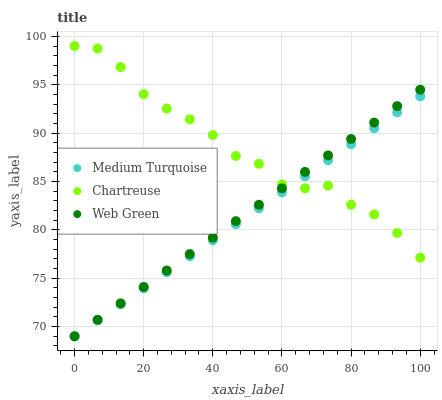Does Medium Turquoise have the minimum area under the curve?
Answer yes or no. Yes. Does Chartreuse have the maximum area under the curve?
Answer yes or no. Yes. Does Web Green have the minimum area under the curve?
Answer yes or no. No. Does Web Green have the maximum area under the curve?
Answer yes or no. No. Is Medium Turquoise the smoothest?
Answer yes or no. Yes. Is Chartreuse the roughest?
Answer yes or no. Yes. Is Web Green the smoothest?
Answer yes or no. No. Is Web Green the roughest?
Answer yes or no. No. Does Web Green have the lowest value?
Answer yes or no. Yes. Does Chartreuse have the highest value?
Answer yes or no. Yes. Does Web Green have the highest value?
Answer yes or no. No. Does Medium Turquoise intersect Web Green?
Answer yes or no. Yes. Is Medium Turquoise less than Web Green?
Answer yes or no. No. Is Medium Turquoise greater than Web Green?
Answer yes or no. No. 